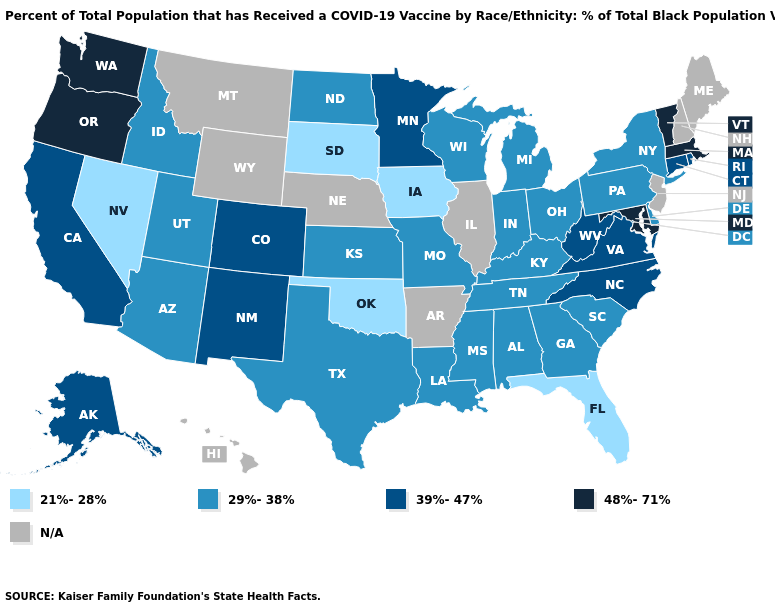Name the states that have a value in the range 48%-71%?
Write a very short answer. Maryland, Massachusetts, Oregon, Vermont, Washington. What is the value of Nevada?
Write a very short answer. 21%-28%. Name the states that have a value in the range 29%-38%?
Quick response, please. Alabama, Arizona, Delaware, Georgia, Idaho, Indiana, Kansas, Kentucky, Louisiana, Michigan, Mississippi, Missouri, New York, North Dakota, Ohio, Pennsylvania, South Carolina, Tennessee, Texas, Utah, Wisconsin. Name the states that have a value in the range 29%-38%?
Answer briefly. Alabama, Arizona, Delaware, Georgia, Idaho, Indiana, Kansas, Kentucky, Louisiana, Michigan, Mississippi, Missouri, New York, North Dakota, Ohio, Pennsylvania, South Carolina, Tennessee, Texas, Utah, Wisconsin. Name the states that have a value in the range 39%-47%?
Quick response, please. Alaska, California, Colorado, Connecticut, Minnesota, New Mexico, North Carolina, Rhode Island, Virginia, West Virginia. Is the legend a continuous bar?
Short answer required. No. What is the value of New York?
Short answer required. 29%-38%. Does Oklahoma have the lowest value in the South?
Quick response, please. Yes. Name the states that have a value in the range 39%-47%?
Be succinct. Alaska, California, Colorado, Connecticut, Minnesota, New Mexico, North Carolina, Rhode Island, Virginia, West Virginia. Does Connecticut have the lowest value in the Northeast?
Short answer required. No. Name the states that have a value in the range 29%-38%?
Answer briefly. Alabama, Arizona, Delaware, Georgia, Idaho, Indiana, Kansas, Kentucky, Louisiana, Michigan, Mississippi, Missouri, New York, North Dakota, Ohio, Pennsylvania, South Carolina, Tennessee, Texas, Utah, Wisconsin. Name the states that have a value in the range 21%-28%?
Give a very brief answer. Florida, Iowa, Nevada, Oklahoma, South Dakota. What is the highest value in the MidWest ?
Concise answer only. 39%-47%. Among the states that border Arkansas , which have the lowest value?
Quick response, please. Oklahoma. Does Connecticut have the lowest value in the Northeast?
Concise answer only. No. 